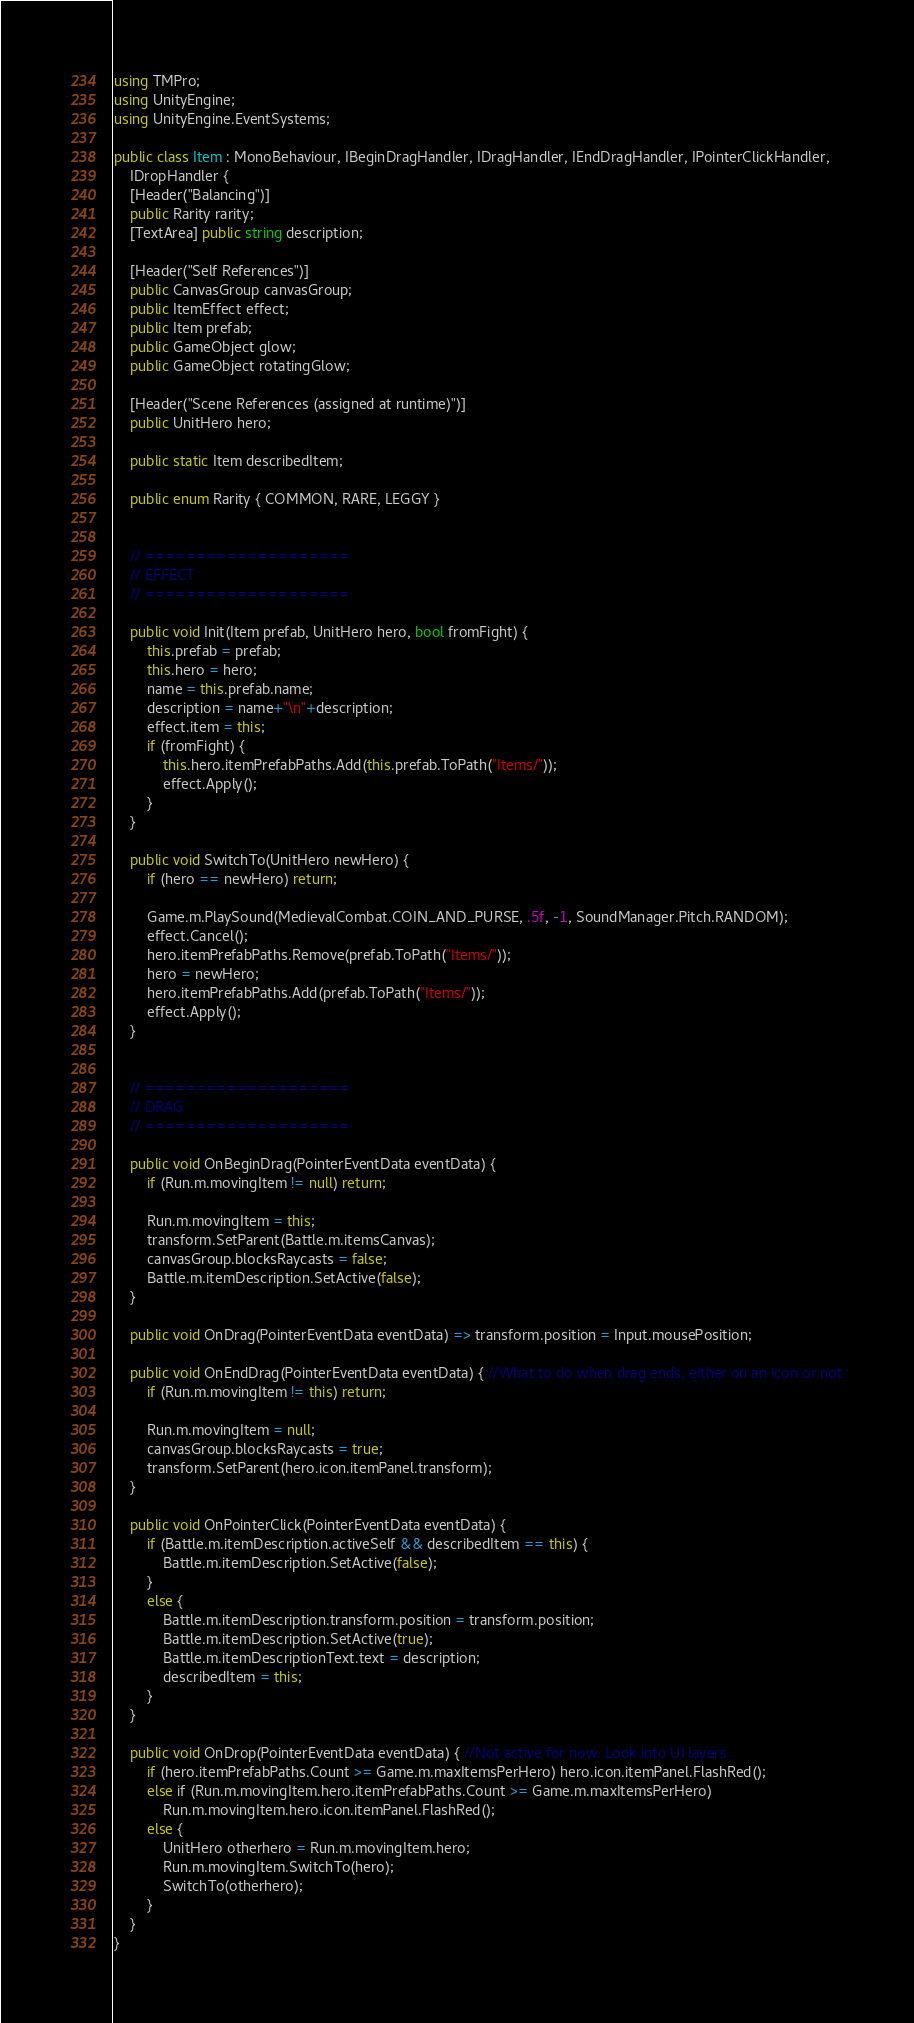<code> <loc_0><loc_0><loc_500><loc_500><_C#_>using TMPro;
using UnityEngine;
using UnityEngine.EventSystems;

public class Item : MonoBehaviour, IBeginDragHandler, IDragHandler, IEndDragHandler, IPointerClickHandler, 
    IDropHandler {
    [Header("Balancing")]
    public Rarity rarity;
    [TextArea] public string description;
    
    [Header("Self References")]
    public CanvasGroup canvasGroup;
    public ItemEffect effect;
    public Item prefab;
    public GameObject glow;
    public GameObject rotatingGlow;
    
    [Header("Scene References (assigned at runtime)")]
    public UnitHero hero;

    public static Item describedItem;
    
    public enum Rarity { COMMON, RARE, LEGGY }

    
    // ====================
    // EFFECT
    // ====================

    public void Init(Item prefab, UnitHero hero, bool fromFight) {
        this.prefab = prefab;
        this.hero = hero;
        name = this.prefab.name;
        description = name+"\n"+description;
        effect.item = this;
        if (fromFight) {
            this.hero.itemPrefabPaths.Add(this.prefab.ToPath("Items/"));
            effect.Apply();
        }
    }

    public void SwitchTo(UnitHero newHero) {
        if (hero == newHero) return;

        Game.m.PlaySound(MedievalCombat.COIN_AND_PURSE, .5f, -1, SoundManager.Pitch.RANDOM);
        effect.Cancel();
        hero.itemPrefabPaths.Remove(prefab.ToPath("Items/"));
        hero = newHero;
        hero.itemPrefabPaths.Add(prefab.ToPath("Items/"));
        effect.Apply();
    }
    
    
    // ====================
    // DRAG
    // ====================

    public void OnBeginDrag(PointerEventData eventData) {
        if (Run.m.movingItem != null) return;
        
        Run.m.movingItem = this;
        transform.SetParent(Battle.m.itemsCanvas);
        canvasGroup.blocksRaycasts = false;
        Battle.m.itemDescription.SetActive(false);
    }

    public void OnDrag(PointerEventData eventData) => transform.position = Input.mousePosition;

    public void OnEndDrag(PointerEventData eventData) { //What to do when drag ends, either on an icon or not
        if (Run.m.movingItem != this) return;
        
        Run.m.movingItem = null;
        canvasGroup.blocksRaycasts = true;
        transform.SetParent(hero.icon.itemPanel.transform);
    }

    public void OnPointerClick(PointerEventData eventData) {
        if (Battle.m.itemDescription.activeSelf && describedItem == this) {
            Battle.m.itemDescription.SetActive(false);
        }
        else {
            Battle.m.itemDescription.transform.position = transform.position;
            Battle.m.itemDescription.SetActive(true);
            Battle.m.itemDescriptionText.text = description;
            describedItem = this;
        }
    }
    
    public void OnDrop(PointerEventData eventData) { //Not active for now. Look into UI layers
        if (hero.itemPrefabPaths.Count >= Game.m.maxItemsPerHero) hero.icon.itemPanel.FlashRed();
        else if (Run.m.movingItem.hero.itemPrefabPaths.Count >= Game.m.maxItemsPerHero) 
            Run.m.movingItem.hero.icon.itemPanel.FlashRed();
        else {
            UnitHero otherhero = Run.m.movingItem.hero;
            Run.m.movingItem.SwitchTo(hero);
            SwitchTo(otherhero);
        }
    }
}</code> 